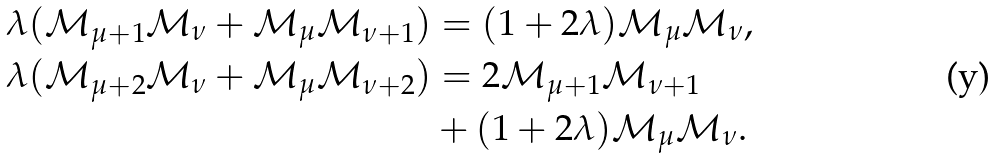<formula> <loc_0><loc_0><loc_500><loc_500>\lambda ( { \mathcal { M } } _ { \mu + 1 } { \mathcal { M } } _ { \nu } + { \mathcal { M } } _ { \mu } { \mathcal { M } } _ { \nu + 1 } ) & = ( 1 + 2 \lambda ) { \mathcal { M } } _ { \mu } { \mathcal { M } } _ { \nu } , \\ \lambda ( { \mathcal { M } } _ { \mu + 2 } { \mathcal { M } } _ { \nu } + { \mathcal { M } } _ { \mu } { \mathcal { M } } _ { \nu + 2 } ) & = 2 { \mathcal { M } } _ { \mu + 1 } { \mathcal { M } } _ { \nu + 1 } \\ & + ( 1 + 2 \lambda ) { \mathcal { M } } _ { \mu } { \mathcal { M } } _ { \nu } .</formula> 